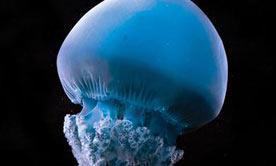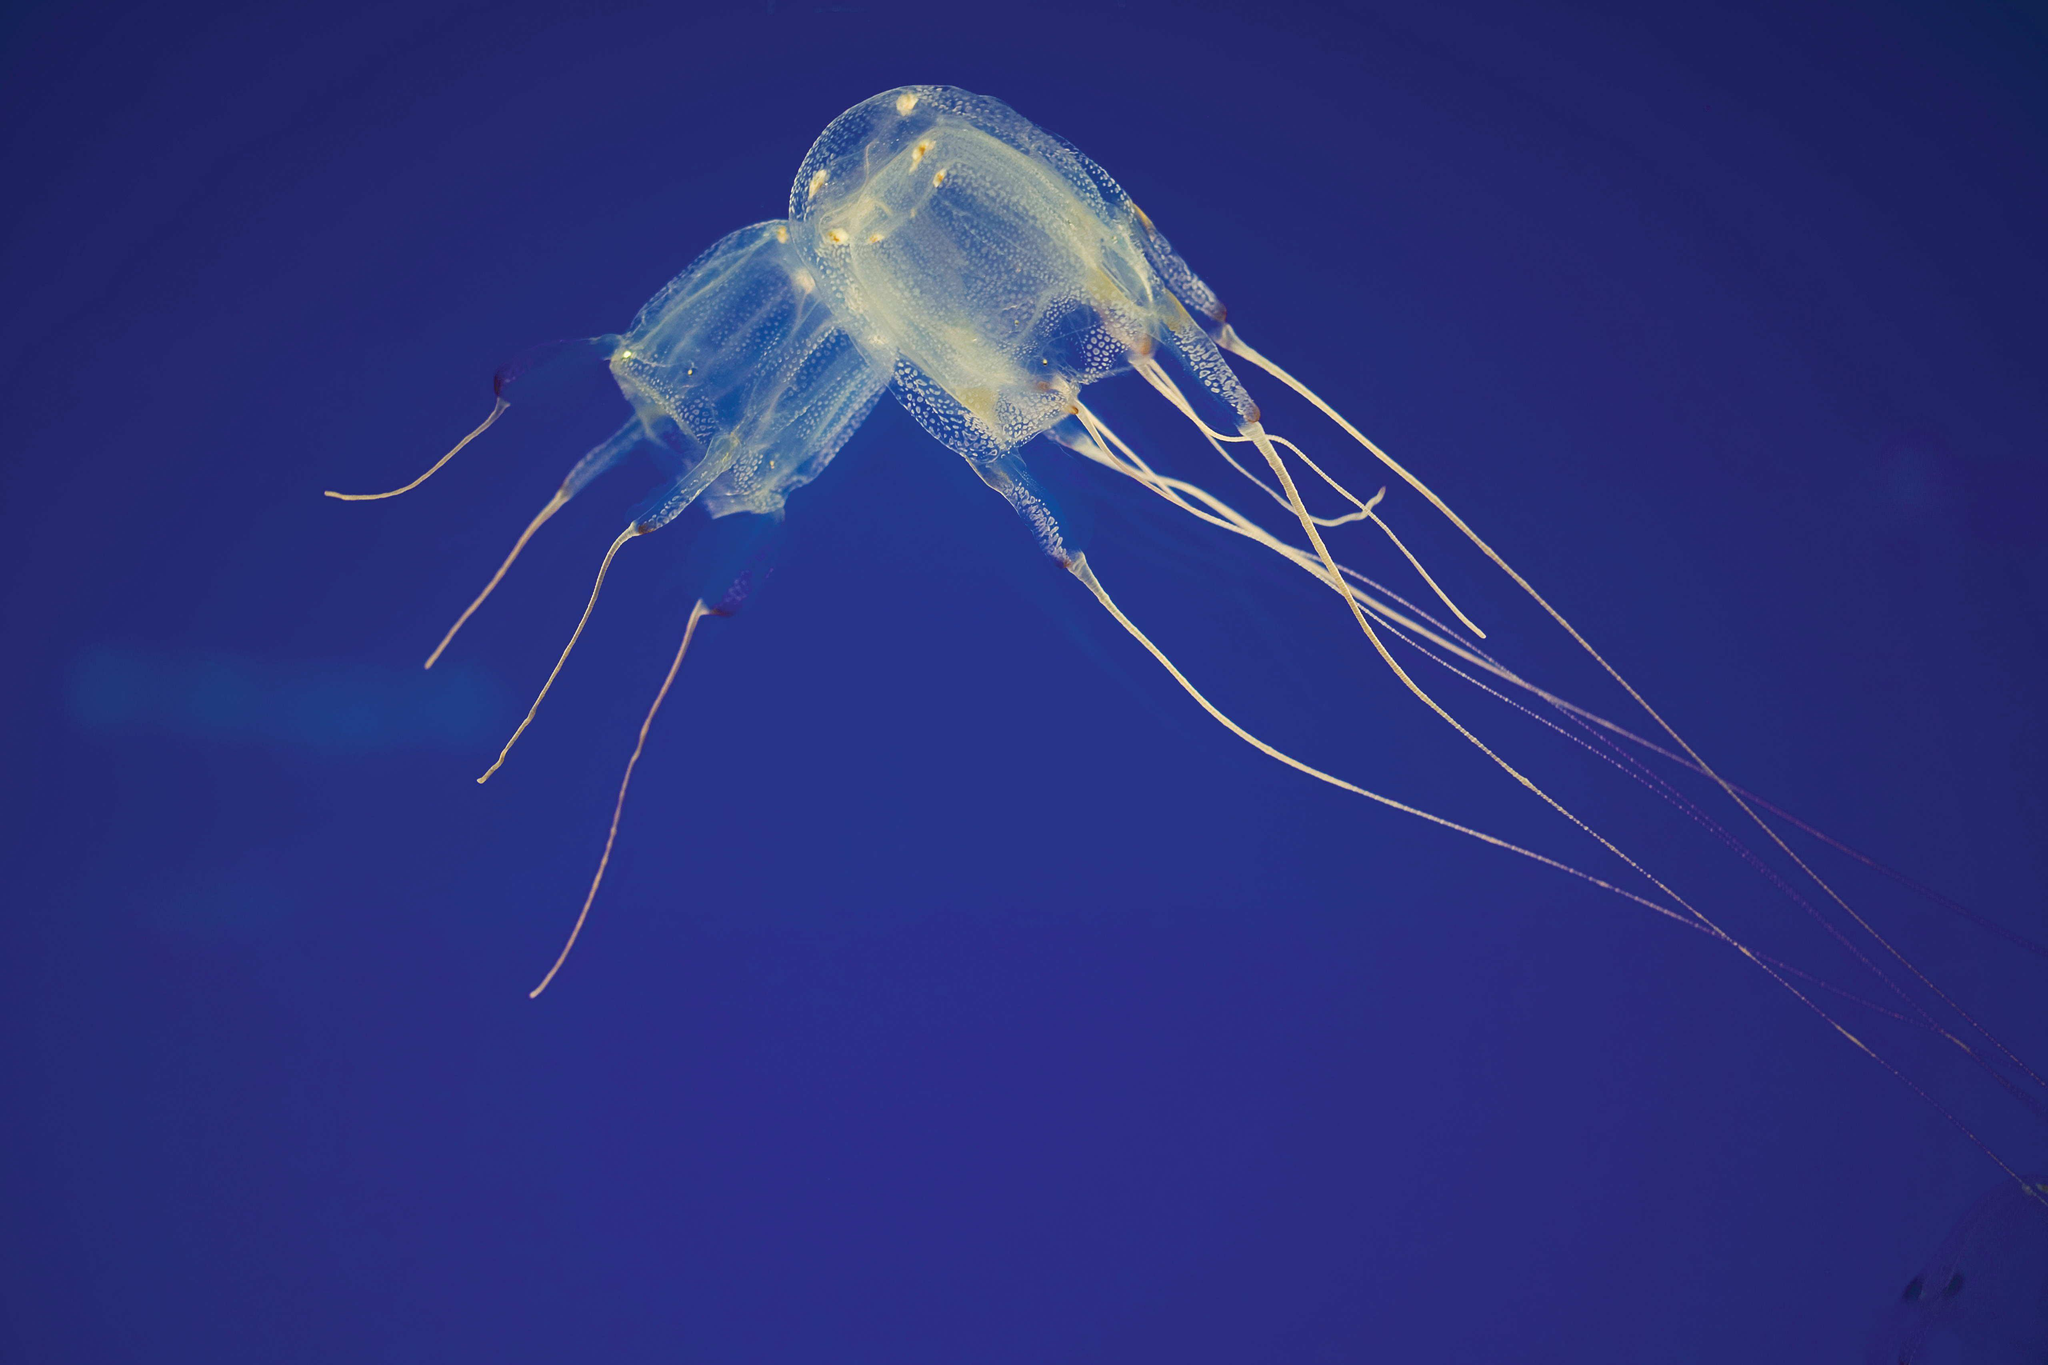The first image is the image on the left, the second image is the image on the right. Examine the images to the left and right. Is the description "The left image contains at least three jelly fish." accurate? Answer yes or no. No. The first image is the image on the left, the second image is the image on the right. For the images shown, is this caption "An image includes a jellyfish with long thread-like tendrils extending backward, to the right." true? Answer yes or no. Yes. 